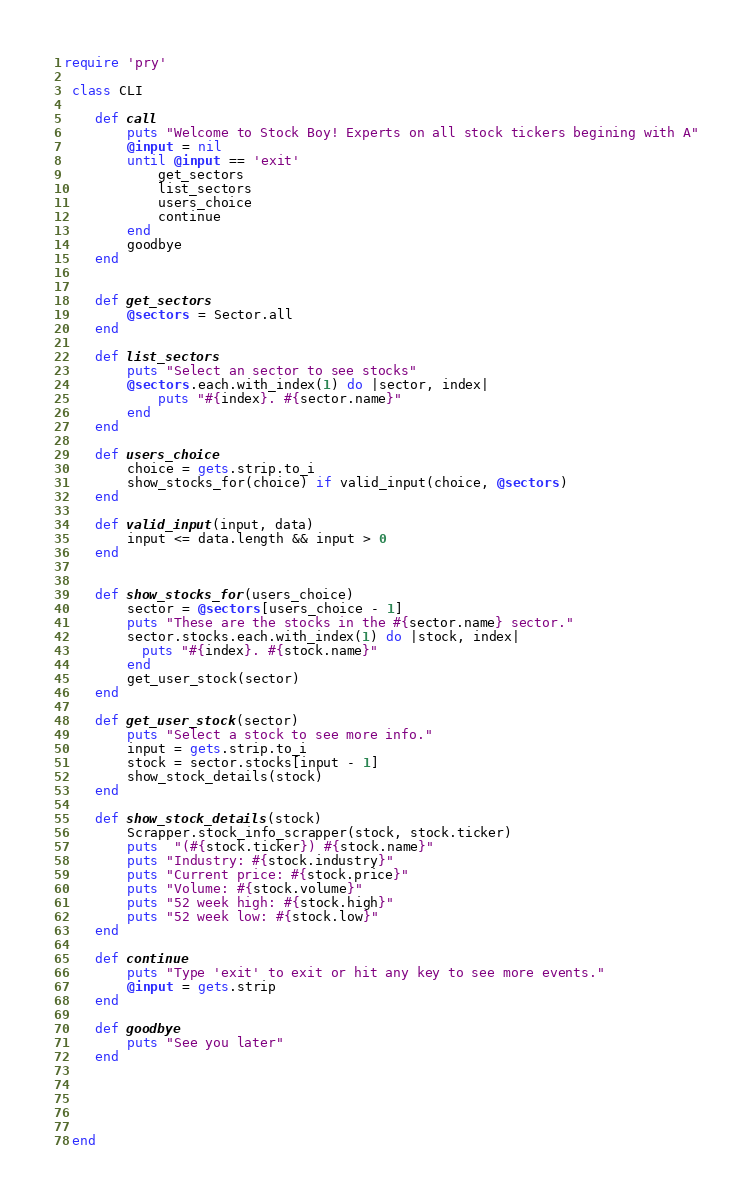<code> <loc_0><loc_0><loc_500><loc_500><_Ruby_>require 'pry'

 class CLI

    def call
        puts "Welcome to Stock Boy! Experts on all stock tickers begining with A"
        @input = nil 
        until @input == 'exit'
            get_sectors
            list_sectors
            users_choice
            continue
        end
        goodbye
    end


    def get_sectors
        @sectors = Sector.all
    end

    def list_sectors
        puts "Select an sector to see stocks"
        @sectors.each.with_index(1) do |sector, index|
            puts "#{index}. #{sector.name}"
        end
    end

    def users_choice
        choice = gets.strip.to_i
        show_stocks_for(choice) if valid_input(choice, @sectors)
    end
    
    def valid_input(input, data)
        input <= data.length && input > 0
    end


    def show_stocks_for(users_choice)
        sector = @sectors[users_choice - 1]
        puts "These are the stocks in the #{sector.name} sector."
        sector.stocks.each.with_index(1) do |stock, index|
          puts "#{index}. #{stock.name}"
        end
        get_user_stock(sector)
    end

    def get_user_stock(sector)
        puts "Select a stock to see more info."
        input = gets.strip.to_i
        stock = sector.stocks[input - 1]
        show_stock_details(stock)
    end

    def show_stock_details(stock)
        Scrapper.stock_info_scrapper(stock, stock.ticker)
        puts  "(#{stock.ticker}) #{stock.name}"
        puts "Industry: #{stock.industry}"
        puts "Current price: #{stock.price}"
        puts "Volume: #{stock.volume}"
        puts "52 week high: #{stock.high}"
        puts "52 week low: #{stock.low}"
    end

    def continue
        puts "Type 'exit' to exit or hit any key to see more events."
        @input = gets.strip
    end

    def goodbye
        puts "See you later"
    end





 end</code> 